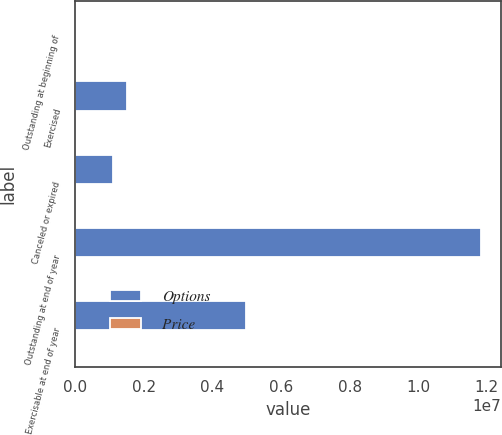Convert chart to OTSL. <chart><loc_0><loc_0><loc_500><loc_500><stacked_bar_chart><ecel><fcel>Outstanding at beginning of<fcel>Exercised<fcel>Canceled or expired<fcel>Outstanding at end of year<fcel>Exercisable at end of year<nl><fcel>Options<fcel>19.93<fcel>1.51358e+06<fcel>1.1021e+06<fcel>1.1838e+07<fcel>4.98718e+06<nl><fcel>Price<fcel>15.31<fcel>6.06<fcel>19.93<fcel>16.07<fcel>11.54<nl></chart> 